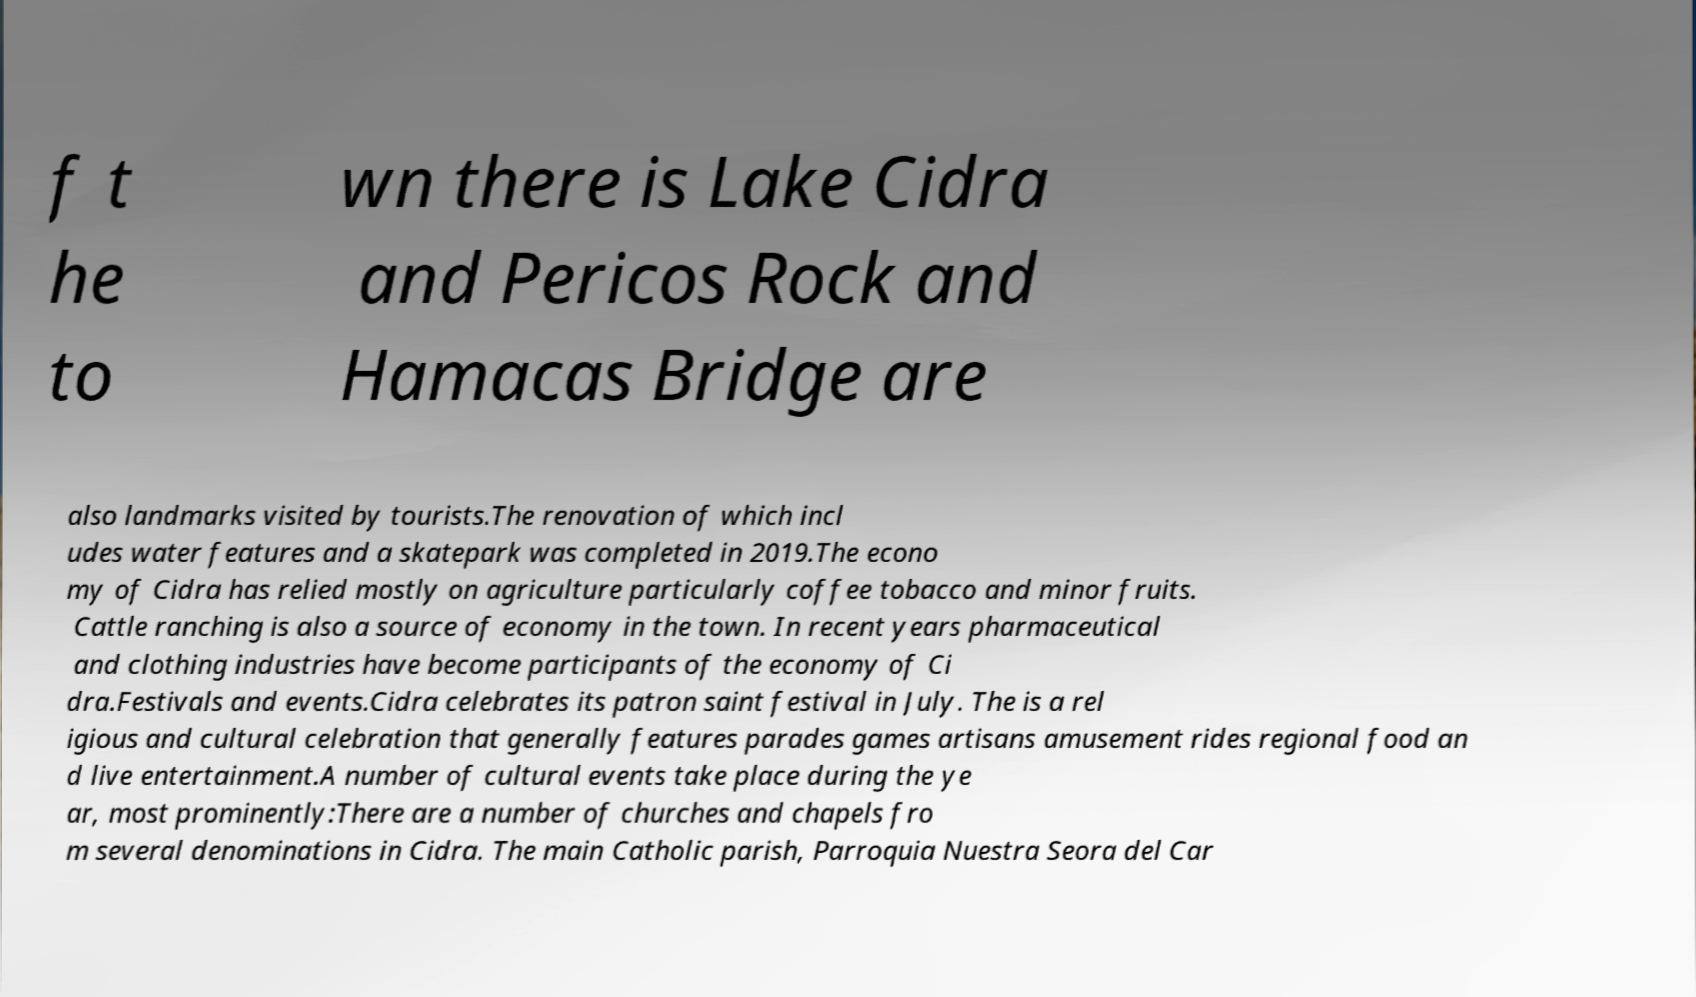What messages or text are displayed in this image? I need them in a readable, typed format. f t he to wn there is Lake Cidra and Pericos Rock and Hamacas Bridge are also landmarks visited by tourists.The renovation of which incl udes water features and a skatepark was completed in 2019.The econo my of Cidra has relied mostly on agriculture particularly coffee tobacco and minor fruits. Cattle ranching is also a source of economy in the town. In recent years pharmaceutical and clothing industries have become participants of the economy of Ci dra.Festivals and events.Cidra celebrates its patron saint festival in July. The is a rel igious and cultural celebration that generally features parades games artisans amusement rides regional food an d live entertainment.A number of cultural events take place during the ye ar, most prominently:There are a number of churches and chapels fro m several denominations in Cidra. The main Catholic parish, Parroquia Nuestra Seora del Car 